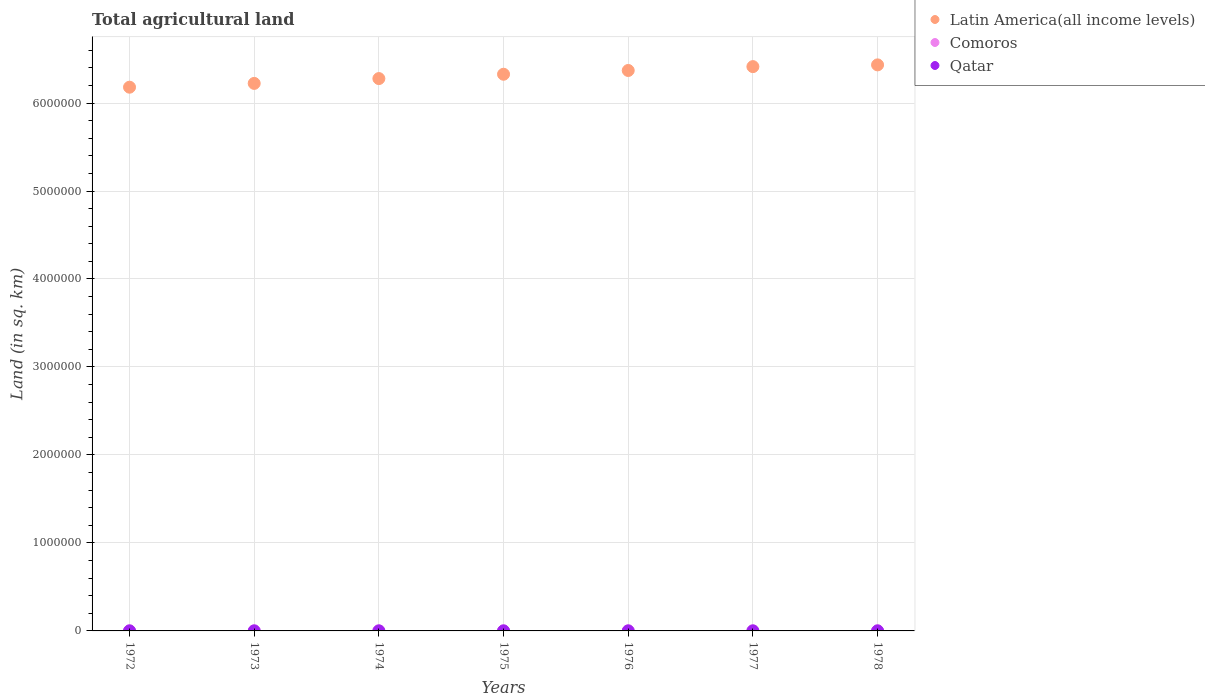How many different coloured dotlines are there?
Give a very brief answer. 3. Is the number of dotlines equal to the number of legend labels?
Provide a short and direct response. Yes. What is the total agricultural land in Comoros in 1974?
Your response must be concise. 950. Across all years, what is the maximum total agricultural land in Latin America(all income levels)?
Keep it short and to the point. 6.43e+06. Across all years, what is the minimum total agricultural land in Qatar?
Keep it short and to the point. 510. In which year was the total agricultural land in Comoros maximum?
Give a very brief answer. 1978. What is the total total agricultural land in Comoros in the graph?
Ensure brevity in your answer.  6700. What is the difference between the total agricultural land in Qatar in 1972 and that in 1976?
Keep it short and to the point. -10. What is the difference between the total agricultural land in Qatar in 1973 and the total agricultural land in Comoros in 1978?
Provide a short and direct response. -490. What is the average total agricultural land in Comoros per year?
Give a very brief answer. 957.14. In the year 1972, what is the difference between the total agricultural land in Latin America(all income levels) and total agricultural land in Comoros?
Make the answer very short. 6.18e+06. What is the ratio of the total agricultural land in Qatar in 1972 to that in 1978?
Your answer should be very brief. 0.98. Is the total agricultural land in Qatar in 1974 less than that in 1978?
Give a very brief answer. No. What is the difference between the highest and the lowest total agricultural land in Latin America(all income levels)?
Provide a short and direct response. 2.54e+05. In how many years, is the total agricultural land in Comoros greater than the average total agricultural land in Comoros taken over all years?
Your response must be concise. 1. Does the total agricultural land in Latin America(all income levels) monotonically increase over the years?
Provide a short and direct response. Yes. Is the total agricultural land in Latin America(all income levels) strictly greater than the total agricultural land in Comoros over the years?
Provide a short and direct response. Yes. How many years are there in the graph?
Your answer should be very brief. 7. What is the difference between two consecutive major ticks on the Y-axis?
Offer a very short reply. 1.00e+06. Does the graph contain any zero values?
Provide a short and direct response. No. Does the graph contain grids?
Offer a terse response. Yes. Where does the legend appear in the graph?
Provide a short and direct response. Top right. How many legend labels are there?
Make the answer very short. 3. What is the title of the graph?
Ensure brevity in your answer.  Total agricultural land. What is the label or title of the Y-axis?
Make the answer very short. Land (in sq. km). What is the Land (in sq. km) in Latin America(all income levels) in 1972?
Offer a very short reply. 6.18e+06. What is the Land (in sq. km) of Comoros in 1972?
Provide a short and direct response. 950. What is the Land (in sq. km) of Qatar in 1972?
Provide a succinct answer. 510. What is the Land (in sq. km) of Latin America(all income levels) in 1973?
Offer a very short reply. 6.22e+06. What is the Land (in sq. km) of Comoros in 1973?
Your answer should be very brief. 950. What is the Land (in sq. km) of Qatar in 1973?
Offer a terse response. 510. What is the Land (in sq. km) in Latin America(all income levels) in 1974?
Your response must be concise. 6.28e+06. What is the Land (in sq. km) of Comoros in 1974?
Give a very brief answer. 950. What is the Land (in sq. km) of Qatar in 1974?
Ensure brevity in your answer.  520. What is the Land (in sq. km) of Latin America(all income levels) in 1975?
Ensure brevity in your answer.  6.33e+06. What is the Land (in sq. km) of Comoros in 1975?
Offer a terse response. 950. What is the Land (in sq. km) of Qatar in 1975?
Your answer should be very brief. 520. What is the Land (in sq. km) of Latin America(all income levels) in 1976?
Ensure brevity in your answer.  6.37e+06. What is the Land (in sq. km) of Comoros in 1976?
Your answer should be very brief. 950. What is the Land (in sq. km) of Qatar in 1976?
Your answer should be compact. 520. What is the Land (in sq. km) in Latin America(all income levels) in 1977?
Your answer should be very brief. 6.41e+06. What is the Land (in sq. km) of Comoros in 1977?
Provide a short and direct response. 950. What is the Land (in sq. km) in Qatar in 1977?
Your answer should be compact. 520. What is the Land (in sq. km) of Latin America(all income levels) in 1978?
Provide a succinct answer. 6.43e+06. What is the Land (in sq. km) in Comoros in 1978?
Offer a terse response. 1000. What is the Land (in sq. km) of Qatar in 1978?
Make the answer very short. 520. Across all years, what is the maximum Land (in sq. km) of Latin America(all income levels)?
Offer a very short reply. 6.43e+06. Across all years, what is the maximum Land (in sq. km) of Qatar?
Your answer should be compact. 520. Across all years, what is the minimum Land (in sq. km) in Latin America(all income levels)?
Offer a very short reply. 6.18e+06. Across all years, what is the minimum Land (in sq. km) of Comoros?
Provide a short and direct response. 950. Across all years, what is the minimum Land (in sq. km) in Qatar?
Ensure brevity in your answer.  510. What is the total Land (in sq. km) of Latin America(all income levels) in the graph?
Keep it short and to the point. 4.42e+07. What is the total Land (in sq. km) of Comoros in the graph?
Give a very brief answer. 6700. What is the total Land (in sq. km) of Qatar in the graph?
Make the answer very short. 3620. What is the difference between the Land (in sq. km) of Latin America(all income levels) in 1972 and that in 1973?
Provide a short and direct response. -4.32e+04. What is the difference between the Land (in sq. km) of Comoros in 1972 and that in 1973?
Ensure brevity in your answer.  0. What is the difference between the Land (in sq. km) in Qatar in 1972 and that in 1973?
Your response must be concise. 0. What is the difference between the Land (in sq. km) in Latin America(all income levels) in 1972 and that in 1974?
Provide a succinct answer. -9.79e+04. What is the difference between the Land (in sq. km) of Latin America(all income levels) in 1972 and that in 1975?
Your answer should be compact. -1.47e+05. What is the difference between the Land (in sq. km) of Qatar in 1972 and that in 1975?
Provide a short and direct response. -10. What is the difference between the Land (in sq. km) in Latin America(all income levels) in 1972 and that in 1976?
Make the answer very short. -1.90e+05. What is the difference between the Land (in sq. km) in Qatar in 1972 and that in 1976?
Give a very brief answer. -10. What is the difference between the Land (in sq. km) in Latin America(all income levels) in 1972 and that in 1977?
Provide a short and direct response. -2.34e+05. What is the difference between the Land (in sq. km) in Qatar in 1972 and that in 1977?
Offer a terse response. -10. What is the difference between the Land (in sq. km) in Latin America(all income levels) in 1972 and that in 1978?
Keep it short and to the point. -2.54e+05. What is the difference between the Land (in sq. km) in Comoros in 1972 and that in 1978?
Your answer should be compact. -50. What is the difference between the Land (in sq. km) in Latin America(all income levels) in 1973 and that in 1974?
Keep it short and to the point. -5.48e+04. What is the difference between the Land (in sq. km) in Comoros in 1973 and that in 1974?
Make the answer very short. 0. What is the difference between the Land (in sq. km) in Latin America(all income levels) in 1973 and that in 1975?
Keep it short and to the point. -1.04e+05. What is the difference between the Land (in sq. km) in Comoros in 1973 and that in 1975?
Your response must be concise. 0. What is the difference between the Land (in sq. km) in Qatar in 1973 and that in 1975?
Keep it short and to the point. -10. What is the difference between the Land (in sq. km) in Latin America(all income levels) in 1973 and that in 1976?
Your response must be concise. -1.47e+05. What is the difference between the Land (in sq. km) of Qatar in 1973 and that in 1976?
Provide a succinct answer. -10. What is the difference between the Land (in sq. km) in Latin America(all income levels) in 1973 and that in 1977?
Keep it short and to the point. -1.91e+05. What is the difference between the Land (in sq. km) of Comoros in 1973 and that in 1977?
Offer a terse response. 0. What is the difference between the Land (in sq. km) of Qatar in 1973 and that in 1977?
Provide a short and direct response. -10. What is the difference between the Land (in sq. km) in Latin America(all income levels) in 1973 and that in 1978?
Keep it short and to the point. -2.11e+05. What is the difference between the Land (in sq. km) of Latin America(all income levels) in 1974 and that in 1975?
Offer a terse response. -4.93e+04. What is the difference between the Land (in sq. km) in Latin America(all income levels) in 1974 and that in 1976?
Your answer should be compact. -9.20e+04. What is the difference between the Land (in sq. km) of Latin America(all income levels) in 1974 and that in 1977?
Ensure brevity in your answer.  -1.36e+05. What is the difference between the Land (in sq. km) of Comoros in 1974 and that in 1977?
Offer a very short reply. 0. What is the difference between the Land (in sq. km) of Qatar in 1974 and that in 1977?
Provide a succinct answer. 0. What is the difference between the Land (in sq. km) in Latin America(all income levels) in 1974 and that in 1978?
Your answer should be compact. -1.56e+05. What is the difference between the Land (in sq. km) of Latin America(all income levels) in 1975 and that in 1976?
Your response must be concise. -4.28e+04. What is the difference between the Land (in sq. km) in Qatar in 1975 and that in 1976?
Provide a succinct answer. 0. What is the difference between the Land (in sq. km) of Latin America(all income levels) in 1975 and that in 1977?
Your response must be concise. -8.66e+04. What is the difference between the Land (in sq. km) of Comoros in 1975 and that in 1977?
Offer a very short reply. 0. What is the difference between the Land (in sq. km) of Qatar in 1975 and that in 1977?
Offer a terse response. 0. What is the difference between the Land (in sq. km) of Latin America(all income levels) in 1975 and that in 1978?
Provide a short and direct response. -1.06e+05. What is the difference between the Land (in sq. km) in Latin America(all income levels) in 1976 and that in 1977?
Give a very brief answer. -4.38e+04. What is the difference between the Land (in sq. km) of Comoros in 1976 and that in 1977?
Ensure brevity in your answer.  0. What is the difference between the Land (in sq. km) of Qatar in 1976 and that in 1977?
Offer a very short reply. 0. What is the difference between the Land (in sq. km) of Latin America(all income levels) in 1976 and that in 1978?
Keep it short and to the point. -6.37e+04. What is the difference between the Land (in sq. km) of Comoros in 1976 and that in 1978?
Give a very brief answer. -50. What is the difference between the Land (in sq. km) of Latin America(all income levels) in 1977 and that in 1978?
Your response must be concise. -1.98e+04. What is the difference between the Land (in sq. km) of Comoros in 1977 and that in 1978?
Offer a terse response. -50. What is the difference between the Land (in sq. km) in Latin America(all income levels) in 1972 and the Land (in sq. km) in Comoros in 1973?
Keep it short and to the point. 6.18e+06. What is the difference between the Land (in sq. km) in Latin America(all income levels) in 1972 and the Land (in sq. km) in Qatar in 1973?
Your answer should be very brief. 6.18e+06. What is the difference between the Land (in sq. km) in Comoros in 1972 and the Land (in sq. km) in Qatar in 1973?
Provide a short and direct response. 440. What is the difference between the Land (in sq. km) of Latin America(all income levels) in 1972 and the Land (in sq. km) of Comoros in 1974?
Offer a very short reply. 6.18e+06. What is the difference between the Land (in sq. km) of Latin America(all income levels) in 1972 and the Land (in sq. km) of Qatar in 1974?
Offer a terse response. 6.18e+06. What is the difference between the Land (in sq. km) of Comoros in 1972 and the Land (in sq. km) of Qatar in 1974?
Give a very brief answer. 430. What is the difference between the Land (in sq. km) of Latin America(all income levels) in 1972 and the Land (in sq. km) of Comoros in 1975?
Keep it short and to the point. 6.18e+06. What is the difference between the Land (in sq. km) in Latin America(all income levels) in 1972 and the Land (in sq. km) in Qatar in 1975?
Give a very brief answer. 6.18e+06. What is the difference between the Land (in sq. km) of Comoros in 1972 and the Land (in sq. km) of Qatar in 1975?
Ensure brevity in your answer.  430. What is the difference between the Land (in sq. km) of Latin America(all income levels) in 1972 and the Land (in sq. km) of Comoros in 1976?
Ensure brevity in your answer.  6.18e+06. What is the difference between the Land (in sq. km) in Latin America(all income levels) in 1972 and the Land (in sq. km) in Qatar in 1976?
Offer a very short reply. 6.18e+06. What is the difference between the Land (in sq. km) in Comoros in 1972 and the Land (in sq. km) in Qatar in 1976?
Your response must be concise. 430. What is the difference between the Land (in sq. km) of Latin America(all income levels) in 1972 and the Land (in sq. km) of Comoros in 1977?
Your response must be concise. 6.18e+06. What is the difference between the Land (in sq. km) in Latin America(all income levels) in 1972 and the Land (in sq. km) in Qatar in 1977?
Make the answer very short. 6.18e+06. What is the difference between the Land (in sq. km) of Comoros in 1972 and the Land (in sq. km) of Qatar in 1977?
Offer a terse response. 430. What is the difference between the Land (in sq. km) of Latin America(all income levels) in 1972 and the Land (in sq. km) of Comoros in 1978?
Your answer should be very brief. 6.18e+06. What is the difference between the Land (in sq. km) of Latin America(all income levels) in 1972 and the Land (in sq. km) of Qatar in 1978?
Your answer should be compact. 6.18e+06. What is the difference between the Land (in sq. km) of Comoros in 1972 and the Land (in sq. km) of Qatar in 1978?
Offer a very short reply. 430. What is the difference between the Land (in sq. km) in Latin America(all income levels) in 1973 and the Land (in sq. km) in Comoros in 1974?
Keep it short and to the point. 6.22e+06. What is the difference between the Land (in sq. km) of Latin America(all income levels) in 1973 and the Land (in sq. km) of Qatar in 1974?
Give a very brief answer. 6.22e+06. What is the difference between the Land (in sq. km) of Comoros in 1973 and the Land (in sq. km) of Qatar in 1974?
Provide a short and direct response. 430. What is the difference between the Land (in sq. km) of Latin America(all income levels) in 1973 and the Land (in sq. km) of Comoros in 1975?
Provide a short and direct response. 6.22e+06. What is the difference between the Land (in sq. km) of Latin America(all income levels) in 1973 and the Land (in sq. km) of Qatar in 1975?
Make the answer very short. 6.22e+06. What is the difference between the Land (in sq. km) in Comoros in 1973 and the Land (in sq. km) in Qatar in 1975?
Your answer should be very brief. 430. What is the difference between the Land (in sq. km) in Latin America(all income levels) in 1973 and the Land (in sq. km) in Comoros in 1976?
Provide a short and direct response. 6.22e+06. What is the difference between the Land (in sq. km) of Latin America(all income levels) in 1973 and the Land (in sq. km) of Qatar in 1976?
Ensure brevity in your answer.  6.22e+06. What is the difference between the Land (in sq. km) in Comoros in 1973 and the Land (in sq. km) in Qatar in 1976?
Offer a terse response. 430. What is the difference between the Land (in sq. km) of Latin America(all income levels) in 1973 and the Land (in sq. km) of Comoros in 1977?
Your answer should be very brief. 6.22e+06. What is the difference between the Land (in sq. km) in Latin America(all income levels) in 1973 and the Land (in sq. km) in Qatar in 1977?
Provide a succinct answer. 6.22e+06. What is the difference between the Land (in sq. km) in Comoros in 1973 and the Land (in sq. km) in Qatar in 1977?
Offer a terse response. 430. What is the difference between the Land (in sq. km) of Latin America(all income levels) in 1973 and the Land (in sq. km) of Comoros in 1978?
Ensure brevity in your answer.  6.22e+06. What is the difference between the Land (in sq. km) of Latin America(all income levels) in 1973 and the Land (in sq. km) of Qatar in 1978?
Provide a short and direct response. 6.22e+06. What is the difference between the Land (in sq. km) in Comoros in 1973 and the Land (in sq. km) in Qatar in 1978?
Make the answer very short. 430. What is the difference between the Land (in sq. km) of Latin America(all income levels) in 1974 and the Land (in sq. km) of Comoros in 1975?
Keep it short and to the point. 6.28e+06. What is the difference between the Land (in sq. km) in Latin America(all income levels) in 1974 and the Land (in sq. km) in Qatar in 1975?
Give a very brief answer. 6.28e+06. What is the difference between the Land (in sq. km) in Comoros in 1974 and the Land (in sq. km) in Qatar in 1975?
Your response must be concise. 430. What is the difference between the Land (in sq. km) in Latin America(all income levels) in 1974 and the Land (in sq. km) in Comoros in 1976?
Keep it short and to the point. 6.28e+06. What is the difference between the Land (in sq. km) in Latin America(all income levels) in 1974 and the Land (in sq. km) in Qatar in 1976?
Ensure brevity in your answer.  6.28e+06. What is the difference between the Land (in sq. km) of Comoros in 1974 and the Land (in sq. km) of Qatar in 1976?
Keep it short and to the point. 430. What is the difference between the Land (in sq. km) in Latin America(all income levels) in 1974 and the Land (in sq. km) in Comoros in 1977?
Offer a terse response. 6.28e+06. What is the difference between the Land (in sq. km) in Latin America(all income levels) in 1974 and the Land (in sq. km) in Qatar in 1977?
Offer a terse response. 6.28e+06. What is the difference between the Land (in sq. km) in Comoros in 1974 and the Land (in sq. km) in Qatar in 1977?
Your answer should be very brief. 430. What is the difference between the Land (in sq. km) in Latin America(all income levels) in 1974 and the Land (in sq. km) in Comoros in 1978?
Your answer should be compact. 6.28e+06. What is the difference between the Land (in sq. km) of Latin America(all income levels) in 1974 and the Land (in sq. km) of Qatar in 1978?
Offer a terse response. 6.28e+06. What is the difference between the Land (in sq. km) in Comoros in 1974 and the Land (in sq. km) in Qatar in 1978?
Ensure brevity in your answer.  430. What is the difference between the Land (in sq. km) in Latin America(all income levels) in 1975 and the Land (in sq. km) in Comoros in 1976?
Offer a very short reply. 6.33e+06. What is the difference between the Land (in sq. km) in Latin America(all income levels) in 1975 and the Land (in sq. km) in Qatar in 1976?
Offer a terse response. 6.33e+06. What is the difference between the Land (in sq. km) of Comoros in 1975 and the Land (in sq. km) of Qatar in 1976?
Your response must be concise. 430. What is the difference between the Land (in sq. km) in Latin America(all income levels) in 1975 and the Land (in sq. km) in Comoros in 1977?
Ensure brevity in your answer.  6.33e+06. What is the difference between the Land (in sq. km) in Latin America(all income levels) in 1975 and the Land (in sq. km) in Qatar in 1977?
Ensure brevity in your answer.  6.33e+06. What is the difference between the Land (in sq. km) in Comoros in 1975 and the Land (in sq. km) in Qatar in 1977?
Your response must be concise. 430. What is the difference between the Land (in sq. km) of Latin America(all income levels) in 1975 and the Land (in sq. km) of Comoros in 1978?
Provide a succinct answer. 6.33e+06. What is the difference between the Land (in sq. km) of Latin America(all income levels) in 1975 and the Land (in sq. km) of Qatar in 1978?
Make the answer very short. 6.33e+06. What is the difference between the Land (in sq. km) in Comoros in 1975 and the Land (in sq. km) in Qatar in 1978?
Provide a succinct answer. 430. What is the difference between the Land (in sq. km) in Latin America(all income levels) in 1976 and the Land (in sq. km) in Comoros in 1977?
Your response must be concise. 6.37e+06. What is the difference between the Land (in sq. km) of Latin America(all income levels) in 1976 and the Land (in sq. km) of Qatar in 1977?
Your answer should be compact. 6.37e+06. What is the difference between the Land (in sq. km) of Comoros in 1976 and the Land (in sq. km) of Qatar in 1977?
Keep it short and to the point. 430. What is the difference between the Land (in sq. km) in Latin America(all income levels) in 1976 and the Land (in sq. km) in Comoros in 1978?
Offer a terse response. 6.37e+06. What is the difference between the Land (in sq. km) of Latin America(all income levels) in 1976 and the Land (in sq. km) of Qatar in 1978?
Make the answer very short. 6.37e+06. What is the difference between the Land (in sq. km) of Comoros in 1976 and the Land (in sq. km) of Qatar in 1978?
Your response must be concise. 430. What is the difference between the Land (in sq. km) of Latin America(all income levels) in 1977 and the Land (in sq. km) of Comoros in 1978?
Your response must be concise. 6.41e+06. What is the difference between the Land (in sq. km) of Latin America(all income levels) in 1977 and the Land (in sq. km) of Qatar in 1978?
Ensure brevity in your answer.  6.41e+06. What is the difference between the Land (in sq. km) of Comoros in 1977 and the Land (in sq. km) of Qatar in 1978?
Offer a very short reply. 430. What is the average Land (in sq. km) in Latin America(all income levels) per year?
Give a very brief answer. 6.32e+06. What is the average Land (in sq. km) in Comoros per year?
Offer a terse response. 957.14. What is the average Land (in sq. km) in Qatar per year?
Keep it short and to the point. 517.14. In the year 1972, what is the difference between the Land (in sq. km) of Latin America(all income levels) and Land (in sq. km) of Comoros?
Your response must be concise. 6.18e+06. In the year 1972, what is the difference between the Land (in sq. km) of Latin America(all income levels) and Land (in sq. km) of Qatar?
Offer a terse response. 6.18e+06. In the year 1972, what is the difference between the Land (in sq. km) of Comoros and Land (in sq. km) of Qatar?
Your answer should be very brief. 440. In the year 1973, what is the difference between the Land (in sq. km) of Latin America(all income levels) and Land (in sq. km) of Comoros?
Provide a succinct answer. 6.22e+06. In the year 1973, what is the difference between the Land (in sq. km) in Latin America(all income levels) and Land (in sq. km) in Qatar?
Give a very brief answer. 6.22e+06. In the year 1973, what is the difference between the Land (in sq. km) in Comoros and Land (in sq. km) in Qatar?
Provide a short and direct response. 440. In the year 1974, what is the difference between the Land (in sq. km) in Latin America(all income levels) and Land (in sq. km) in Comoros?
Keep it short and to the point. 6.28e+06. In the year 1974, what is the difference between the Land (in sq. km) of Latin America(all income levels) and Land (in sq. km) of Qatar?
Keep it short and to the point. 6.28e+06. In the year 1974, what is the difference between the Land (in sq. km) of Comoros and Land (in sq. km) of Qatar?
Your answer should be very brief. 430. In the year 1975, what is the difference between the Land (in sq. km) of Latin America(all income levels) and Land (in sq. km) of Comoros?
Make the answer very short. 6.33e+06. In the year 1975, what is the difference between the Land (in sq. km) in Latin America(all income levels) and Land (in sq. km) in Qatar?
Give a very brief answer. 6.33e+06. In the year 1975, what is the difference between the Land (in sq. km) in Comoros and Land (in sq. km) in Qatar?
Make the answer very short. 430. In the year 1976, what is the difference between the Land (in sq. km) of Latin America(all income levels) and Land (in sq. km) of Comoros?
Ensure brevity in your answer.  6.37e+06. In the year 1976, what is the difference between the Land (in sq. km) in Latin America(all income levels) and Land (in sq. km) in Qatar?
Your answer should be very brief. 6.37e+06. In the year 1976, what is the difference between the Land (in sq. km) of Comoros and Land (in sq. km) of Qatar?
Give a very brief answer. 430. In the year 1977, what is the difference between the Land (in sq. km) of Latin America(all income levels) and Land (in sq. km) of Comoros?
Provide a succinct answer. 6.41e+06. In the year 1977, what is the difference between the Land (in sq. km) in Latin America(all income levels) and Land (in sq. km) in Qatar?
Provide a short and direct response. 6.41e+06. In the year 1977, what is the difference between the Land (in sq. km) of Comoros and Land (in sq. km) of Qatar?
Your response must be concise. 430. In the year 1978, what is the difference between the Land (in sq. km) of Latin America(all income levels) and Land (in sq. km) of Comoros?
Give a very brief answer. 6.43e+06. In the year 1978, what is the difference between the Land (in sq. km) in Latin America(all income levels) and Land (in sq. km) in Qatar?
Keep it short and to the point. 6.43e+06. In the year 1978, what is the difference between the Land (in sq. km) of Comoros and Land (in sq. km) of Qatar?
Make the answer very short. 480. What is the ratio of the Land (in sq. km) in Qatar in 1972 to that in 1973?
Your response must be concise. 1. What is the ratio of the Land (in sq. km) in Latin America(all income levels) in 1972 to that in 1974?
Provide a succinct answer. 0.98. What is the ratio of the Land (in sq. km) of Comoros in 1972 to that in 1974?
Offer a very short reply. 1. What is the ratio of the Land (in sq. km) of Qatar in 1972 to that in 1974?
Give a very brief answer. 0.98. What is the ratio of the Land (in sq. km) in Latin America(all income levels) in 1972 to that in 1975?
Your answer should be compact. 0.98. What is the ratio of the Land (in sq. km) in Comoros in 1972 to that in 1975?
Provide a succinct answer. 1. What is the ratio of the Land (in sq. km) of Qatar in 1972 to that in 1975?
Keep it short and to the point. 0.98. What is the ratio of the Land (in sq. km) in Latin America(all income levels) in 1972 to that in 1976?
Make the answer very short. 0.97. What is the ratio of the Land (in sq. km) of Qatar in 1972 to that in 1976?
Your response must be concise. 0.98. What is the ratio of the Land (in sq. km) in Latin America(all income levels) in 1972 to that in 1977?
Your response must be concise. 0.96. What is the ratio of the Land (in sq. km) in Qatar in 1972 to that in 1977?
Your response must be concise. 0.98. What is the ratio of the Land (in sq. km) in Latin America(all income levels) in 1972 to that in 1978?
Your answer should be compact. 0.96. What is the ratio of the Land (in sq. km) in Qatar in 1972 to that in 1978?
Offer a very short reply. 0.98. What is the ratio of the Land (in sq. km) of Qatar in 1973 to that in 1974?
Offer a very short reply. 0.98. What is the ratio of the Land (in sq. km) in Latin America(all income levels) in 1973 to that in 1975?
Provide a succinct answer. 0.98. What is the ratio of the Land (in sq. km) of Qatar in 1973 to that in 1975?
Offer a very short reply. 0.98. What is the ratio of the Land (in sq. km) of Latin America(all income levels) in 1973 to that in 1976?
Your answer should be compact. 0.98. What is the ratio of the Land (in sq. km) in Qatar in 1973 to that in 1976?
Ensure brevity in your answer.  0.98. What is the ratio of the Land (in sq. km) of Latin America(all income levels) in 1973 to that in 1977?
Ensure brevity in your answer.  0.97. What is the ratio of the Land (in sq. km) in Qatar in 1973 to that in 1977?
Keep it short and to the point. 0.98. What is the ratio of the Land (in sq. km) in Latin America(all income levels) in 1973 to that in 1978?
Your response must be concise. 0.97. What is the ratio of the Land (in sq. km) of Comoros in 1973 to that in 1978?
Make the answer very short. 0.95. What is the ratio of the Land (in sq. km) in Qatar in 1973 to that in 1978?
Your response must be concise. 0.98. What is the ratio of the Land (in sq. km) of Latin America(all income levels) in 1974 to that in 1975?
Keep it short and to the point. 0.99. What is the ratio of the Land (in sq. km) of Qatar in 1974 to that in 1975?
Keep it short and to the point. 1. What is the ratio of the Land (in sq. km) in Latin America(all income levels) in 1974 to that in 1976?
Provide a succinct answer. 0.99. What is the ratio of the Land (in sq. km) of Comoros in 1974 to that in 1976?
Your answer should be very brief. 1. What is the ratio of the Land (in sq. km) of Qatar in 1974 to that in 1976?
Your answer should be compact. 1. What is the ratio of the Land (in sq. km) in Latin America(all income levels) in 1974 to that in 1977?
Your response must be concise. 0.98. What is the ratio of the Land (in sq. km) in Comoros in 1974 to that in 1977?
Offer a very short reply. 1. What is the ratio of the Land (in sq. km) of Latin America(all income levels) in 1974 to that in 1978?
Provide a short and direct response. 0.98. What is the ratio of the Land (in sq. km) in Comoros in 1975 to that in 1976?
Make the answer very short. 1. What is the ratio of the Land (in sq. km) in Qatar in 1975 to that in 1976?
Your answer should be compact. 1. What is the ratio of the Land (in sq. km) of Latin America(all income levels) in 1975 to that in 1977?
Make the answer very short. 0.99. What is the ratio of the Land (in sq. km) in Comoros in 1975 to that in 1977?
Offer a terse response. 1. What is the ratio of the Land (in sq. km) in Qatar in 1975 to that in 1977?
Provide a short and direct response. 1. What is the ratio of the Land (in sq. km) in Latin America(all income levels) in 1975 to that in 1978?
Give a very brief answer. 0.98. What is the ratio of the Land (in sq. km) of Comoros in 1975 to that in 1978?
Keep it short and to the point. 0.95. What is the ratio of the Land (in sq. km) of Qatar in 1975 to that in 1978?
Your answer should be very brief. 1. What is the ratio of the Land (in sq. km) in Comoros in 1976 to that in 1977?
Offer a terse response. 1. What is the ratio of the Land (in sq. km) in Qatar in 1976 to that in 1977?
Make the answer very short. 1. What is the ratio of the Land (in sq. km) of Comoros in 1976 to that in 1978?
Ensure brevity in your answer.  0.95. What is the ratio of the Land (in sq. km) of Qatar in 1977 to that in 1978?
Provide a short and direct response. 1. What is the difference between the highest and the second highest Land (in sq. km) of Latin America(all income levels)?
Offer a very short reply. 1.98e+04. What is the difference between the highest and the second highest Land (in sq. km) of Comoros?
Your response must be concise. 50. What is the difference between the highest and the second highest Land (in sq. km) of Qatar?
Keep it short and to the point. 0. What is the difference between the highest and the lowest Land (in sq. km) in Latin America(all income levels)?
Your answer should be compact. 2.54e+05. What is the difference between the highest and the lowest Land (in sq. km) of Comoros?
Offer a very short reply. 50. 